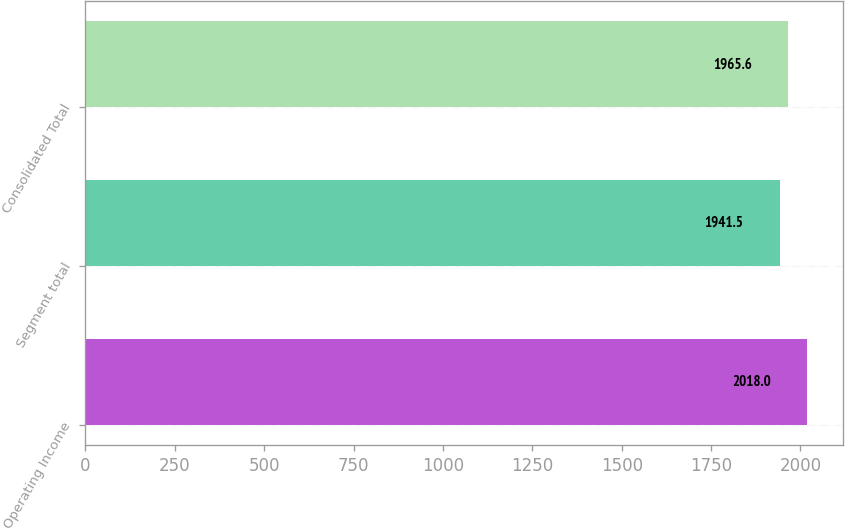Convert chart. <chart><loc_0><loc_0><loc_500><loc_500><bar_chart><fcel>Operating Income<fcel>Segment total<fcel>Consolidated Total<nl><fcel>2018<fcel>1941.5<fcel>1965.6<nl></chart> 